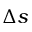Convert formula to latex. <formula><loc_0><loc_0><loc_500><loc_500>\Delta s</formula> 